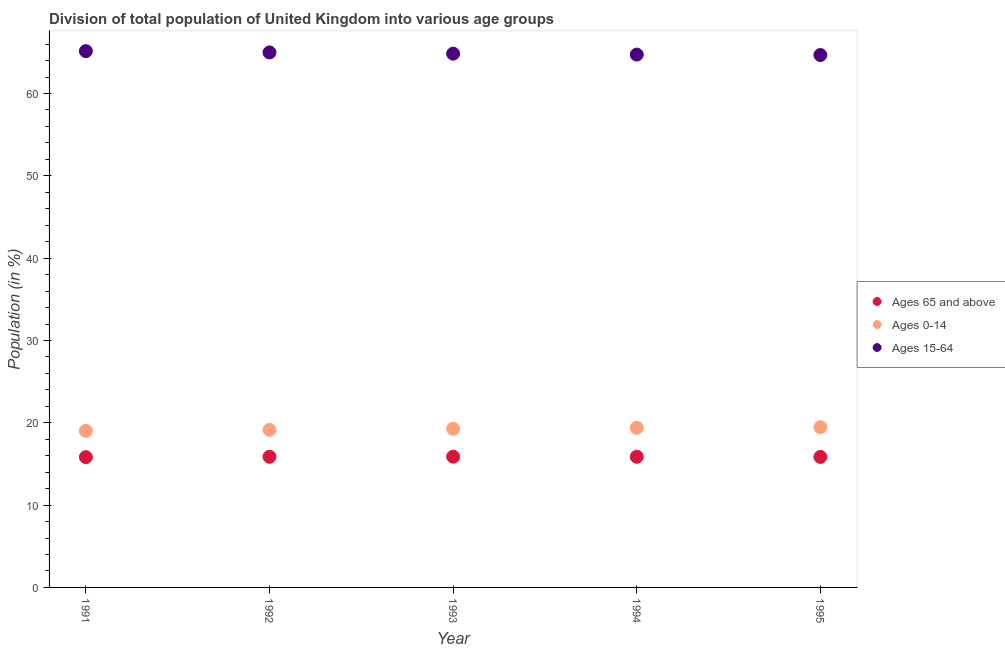What is the percentage of population within the age-group 15-64 in 1993?
Offer a very short reply. 64.84. Across all years, what is the maximum percentage of population within the age-group of 65 and above?
Ensure brevity in your answer.  15.88. Across all years, what is the minimum percentage of population within the age-group 0-14?
Provide a succinct answer. 19.03. In which year was the percentage of population within the age-group of 65 and above maximum?
Your answer should be compact. 1993. What is the total percentage of population within the age-group of 65 and above in the graph?
Ensure brevity in your answer.  79.31. What is the difference between the percentage of population within the age-group 15-64 in 1992 and that in 1994?
Offer a terse response. 0.26. What is the difference between the percentage of population within the age-group 15-64 in 1993 and the percentage of population within the age-group of 65 and above in 1991?
Offer a very short reply. 49.01. What is the average percentage of population within the age-group 15-64 per year?
Keep it short and to the point. 64.88. In the year 1991, what is the difference between the percentage of population within the age-group of 65 and above and percentage of population within the age-group 0-14?
Make the answer very short. -3.2. What is the ratio of the percentage of population within the age-group 15-64 in 1993 to that in 1994?
Provide a succinct answer. 1. What is the difference between the highest and the second highest percentage of population within the age-group 0-14?
Make the answer very short. 0.07. What is the difference between the highest and the lowest percentage of population within the age-group of 65 and above?
Keep it short and to the point. 0.06. Is the sum of the percentage of population within the age-group of 65 and above in 1994 and 1995 greater than the maximum percentage of population within the age-group 0-14 across all years?
Your answer should be compact. Yes. Is it the case that in every year, the sum of the percentage of population within the age-group of 65 and above and percentage of population within the age-group 0-14 is greater than the percentage of population within the age-group 15-64?
Your response must be concise. No. Does the percentage of population within the age-group 0-14 monotonically increase over the years?
Provide a short and direct response. Yes. How many years are there in the graph?
Your response must be concise. 5. What is the difference between two consecutive major ticks on the Y-axis?
Provide a short and direct response. 10. Are the values on the major ticks of Y-axis written in scientific E-notation?
Your response must be concise. No. What is the title of the graph?
Offer a terse response. Division of total population of United Kingdom into various age groups
. What is the label or title of the X-axis?
Give a very brief answer. Year. What is the Population (in %) of Ages 65 and above in 1991?
Your response must be concise. 15.83. What is the Population (in %) of Ages 0-14 in 1991?
Give a very brief answer. 19.03. What is the Population (in %) in Ages 15-64 in 1991?
Your response must be concise. 65.15. What is the Population (in %) of Ages 65 and above in 1992?
Offer a very short reply. 15.87. What is the Population (in %) of Ages 0-14 in 1992?
Provide a succinct answer. 19.14. What is the Population (in %) of Ages 15-64 in 1992?
Provide a short and direct response. 64.99. What is the Population (in %) in Ages 65 and above in 1993?
Provide a succinct answer. 15.88. What is the Population (in %) in Ages 0-14 in 1993?
Offer a very short reply. 19.28. What is the Population (in %) of Ages 15-64 in 1993?
Keep it short and to the point. 64.84. What is the Population (in %) in Ages 65 and above in 1994?
Provide a succinct answer. 15.87. What is the Population (in %) of Ages 0-14 in 1994?
Keep it short and to the point. 19.4. What is the Population (in %) of Ages 15-64 in 1994?
Keep it short and to the point. 64.73. What is the Population (in %) of Ages 65 and above in 1995?
Ensure brevity in your answer.  15.85. What is the Population (in %) of Ages 0-14 in 1995?
Your answer should be very brief. 19.47. What is the Population (in %) of Ages 15-64 in 1995?
Provide a short and direct response. 64.68. Across all years, what is the maximum Population (in %) of Ages 65 and above?
Your answer should be compact. 15.88. Across all years, what is the maximum Population (in %) in Ages 0-14?
Your answer should be very brief. 19.47. Across all years, what is the maximum Population (in %) in Ages 15-64?
Your response must be concise. 65.15. Across all years, what is the minimum Population (in %) in Ages 65 and above?
Offer a very short reply. 15.83. Across all years, what is the minimum Population (in %) of Ages 0-14?
Offer a very short reply. 19.03. Across all years, what is the minimum Population (in %) in Ages 15-64?
Make the answer very short. 64.68. What is the total Population (in %) in Ages 65 and above in the graph?
Make the answer very short. 79.31. What is the total Population (in %) of Ages 0-14 in the graph?
Your answer should be very brief. 96.3. What is the total Population (in %) in Ages 15-64 in the graph?
Make the answer very short. 324.38. What is the difference between the Population (in %) of Ages 65 and above in 1991 and that in 1992?
Your response must be concise. -0.05. What is the difference between the Population (in %) of Ages 0-14 in 1991 and that in 1992?
Keep it short and to the point. -0.11. What is the difference between the Population (in %) of Ages 15-64 in 1991 and that in 1992?
Offer a very short reply. 0.16. What is the difference between the Population (in %) in Ages 65 and above in 1991 and that in 1993?
Your answer should be very brief. -0.06. What is the difference between the Population (in %) of Ages 0-14 in 1991 and that in 1993?
Your answer should be compact. -0.25. What is the difference between the Population (in %) of Ages 15-64 in 1991 and that in 1993?
Provide a succinct answer. 0.31. What is the difference between the Population (in %) of Ages 65 and above in 1991 and that in 1994?
Make the answer very short. -0.05. What is the difference between the Population (in %) in Ages 0-14 in 1991 and that in 1994?
Offer a terse response. -0.37. What is the difference between the Population (in %) of Ages 15-64 in 1991 and that in 1994?
Keep it short and to the point. 0.42. What is the difference between the Population (in %) in Ages 65 and above in 1991 and that in 1995?
Your answer should be compact. -0.03. What is the difference between the Population (in %) in Ages 0-14 in 1991 and that in 1995?
Provide a short and direct response. -0.44. What is the difference between the Population (in %) of Ages 15-64 in 1991 and that in 1995?
Keep it short and to the point. 0.47. What is the difference between the Population (in %) of Ages 65 and above in 1992 and that in 1993?
Keep it short and to the point. -0.01. What is the difference between the Population (in %) of Ages 0-14 in 1992 and that in 1993?
Your response must be concise. -0.14. What is the difference between the Population (in %) of Ages 15-64 in 1992 and that in 1993?
Ensure brevity in your answer.  0.15. What is the difference between the Population (in %) of Ages 65 and above in 1992 and that in 1994?
Offer a terse response. -0. What is the difference between the Population (in %) of Ages 0-14 in 1992 and that in 1994?
Offer a very short reply. -0.26. What is the difference between the Population (in %) of Ages 15-64 in 1992 and that in 1994?
Offer a terse response. 0.26. What is the difference between the Population (in %) of Ages 65 and above in 1992 and that in 1995?
Ensure brevity in your answer.  0.02. What is the difference between the Population (in %) in Ages 0-14 in 1992 and that in 1995?
Offer a terse response. -0.33. What is the difference between the Population (in %) of Ages 15-64 in 1992 and that in 1995?
Ensure brevity in your answer.  0.32. What is the difference between the Population (in %) of Ages 65 and above in 1993 and that in 1994?
Your response must be concise. 0.01. What is the difference between the Population (in %) of Ages 0-14 in 1993 and that in 1994?
Provide a succinct answer. -0.12. What is the difference between the Population (in %) of Ages 15-64 in 1993 and that in 1994?
Your response must be concise. 0.11. What is the difference between the Population (in %) of Ages 65 and above in 1993 and that in 1995?
Provide a succinct answer. 0.03. What is the difference between the Population (in %) in Ages 0-14 in 1993 and that in 1995?
Provide a short and direct response. -0.19. What is the difference between the Population (in %) in Ages 15-64 in 1993 and that in 1995?
Provide a short and direct response. 0.16. What is the difference between the Population (in %) of Ages 65 and above in 1994 and that in 1995?
Provide a short and direct response. 0.02. What is the difference between the Population (in %) of Ages 0-14 in 1994 and that in 1995?
Your answer should be compact. -0.07. What is the difference between the Population (in %) in Ages 15-64 in 1994 and that in 1995?
Make the answer very short. 0.05. What is the difference between the Population (in %) of Ages 65 and above in 1991 and the Population (in %) of Ages 0-14 in 1992?
Your answer should be compact. -3.31. What is the difference between the Population (in %) in Ages 65 and above in 1991 and the Population (in %) in Ages 15-64 in 1992?
Make the answer very short. -49.17. What is the difference between the Population (in %) of Ages 0-14 in 1991 and the Population (in %) of Ages 15-64 in 1992?
Give a very brief answer. -45.97. What is the difference between the Population (in %) of Ages 65 and above in 1991 and the Population (in %) of Ages 0-14 in 1993?
Your answer should be compact. -3.45. What is the difference between the Population (in %) in Ages 65 and above in 1991 and the Population (in %) in Ages 15-64 in 1993?
Your answer should be very brief. -49.01. What is the difference between the Population (in %) in Ages 0-14 in 1991 and the Population (in %) in Ages 15-64 in 1993?
Offer a very short reply. -45.81. What is the difference between the Population (in %) of Ages 65 and above in 1991 and the Population (in %) of Ages 0-14 in 1994?
Offer a very short reply. -3.57. What is the difference between the Population (in %) in Ages 65 and above in 1991 and the Population (in %) in Ages 15-64 in 1994?
Give a very brief answer. -48.9. What is the difference between the Population (in %) of Ages 0-14 in 1991 and the Population (in %) of Ages 15-64 in 1994?
Your answer should be very brief. -45.7. What is the difference between the Population (in %) in Ages 65 and above in 1991 and the Population (in %) in Ages 0-14 in 1995?
Keep it short and to the point. -3.64. What is the difference between the Population (in %) in Ages 65 and above in 1991 and the Population (in %) in Ages 15-64 in 1995?
Give a very brief answer. -48.85. What is the difference between the Population (in %) of Ages 0-14 in 1991 and the Population (in %) of Ages 15-64 in 1995?
Your answer should be compact. -45.65. What is the difference between the Population (in %) in Ages 65 and above in 1992 and the Population (in %) in Ages 0-14 in 1993?
Keep it short and to the point. -3.4. What is the difference between the Population (in %) of Ages 65 and above in 1992 and the Population (in %) of Ages 15-64 in 1993?
Give a very brief answer. -48.97. What is the difference between the Population (in %) in Ages 0-14 in 1992 and the Population (in %) in Ages 15-64 in 1993?
Your answer should be compact. -45.7. What is the difference between the Population (in %) in Ages 65 and above in 1992 and the Population (in %) in Ages 0-14 in 1994?
Provide a succinct answer. -3.52. What is the difference between the Population (in %) of Ages 65 and above in 1992 and the Population (in %) of Ages 15-64 in 1994?
Ensure brevity in your answer.  -48.86. What is the difference between the Population (in %) of Ages 0-14 in 1992 and the Population (in %) of Ages 15-64 in 1994?
Give a very brief answer. -45.59. What is the difference between the Population (in %) of Ages 65 and above in 1992 and the Population (in %) of Ages 0-14 in 1995?
Your answer should be compact. -3.6. What is the difference between the Population (in %) in Ages 65 and above in 1992 and the Population (in %) in Ages 15-64 in 1995?
Give a very brief answer. -48.8. What is the difference between the Population (in %) in Ages 0-14 in 1992 and the Population (in %) in Ages 15-64 in 1995?
Keep it short and to the point. -45.54. What is the difference between the Population (in %) of Ages 65 and above in 1993 and the Population (in %) of Ages 0-14 in 1994?
Offer a very short reply. -3.51. What is the difference between the Population (in %) in Ages 65 and above in 1993 and the Population (in %) in Ages 15-64 in 1994?
Ensure brevity in your answer.  -48.84. What is the difference between the Population (in %) of Ages 0-14 in 1993 and the Population (in %) of Ages 15-64 in 1994?
Offer a very short reply. -45.45. What is the difference between the Population (in %) of Ages 65 and above in 1993 and the Population (in %) of Ages 0-14 in 1995?
Provide a succinct answer. -3.59. What is the difference between the Population (in %) in Ages 65 and above in 1993 and the Population (in %) in Ages 15-64 in 1995?
Provide a succinct answer. -48.79. What is the difference between the Population (in %) in Ages 0-14 in 1993 and the Population (in %) in Ages 15-64 in 1995?
Offer a very short reply. -45.4. What is the difference between the Population (in %) of Ages 65 and above in 1994 and the Population (in %) of Ages 0-14 in 1995?
Your answer should be very brief. -3.59. What is the difference between the Population (in %) of Ages 65 and above in 1994 and the Population (in %) of Ages 15-64 in 1995?
Your answer should be very brief. -48.8. What is the difference between the Population (in %) in Ages 0-14 in 1994 and the Population (in %) in Ages 15-64 in 1995?
Offer a terse response. -45.28. What is the average Population (in %) in Ages 65 and above per year?
Offer a terse response. 15.86. What is the average Population (in %) in Ages 0-14 per year?
Provide a short and direct response. 19.26. What is the average Population (in %) in Ages 15-64 per year?
Give a very brief answer. 64.88. In the year 1991, what is the difference between the Population (in %) of Ages 65 and above and Population (in %) of Ages 0-14?
Your answer should be very brief. -3.2. In the year 1991, what is the difference between the Population (in %) of Ages 65 and above and Population (in %) of Ages 15-64?
Your answer should be very brief. -49.32. In the year 1991, what is the difference between the Population (in %) in Ages 0-14 and Population (in %) in Ages 15-64?
Give a very brief answer. -46.12. In the year 1992, what is the difference between the Population (in %) in Ages 65 and above and Population (in %) in Ages 0-14?
Offer a terse response. -3.26. In the year 1992, what is the difference between the Population (in %) in Ages 65 and above and Population (in %) in Ages 15-64?
Your answer should be very brief. -49.12. In the year 1992, what is the difference between the Population (in %) of Ages 0-14 and Population (in %) of Ages 15-64?
Give a very brief answer. -45.85. In the year 1993, what is the difference between the Population (in %) in Ages 65 and above and Population (in %) in Ages 0-14?
Give a very brief answer. -3.39. In the year 1993, what is the difference between the Population (in %) in Ages 65 and above and Population (in %) in Ages 15-64?
Your answer should be compact. -48.96. In the year 1993, what is the difference between the Population (in %) in Ages 0-14 and Population (in %) in Ages 15-64?
Keep it short and to the point. -45.56. In the year 1994, what is the difference between the Population (in %) of Ages 65 and above and Population (in %) of Ages 0-14?
Provide a succinct answer. -3.52. In the year 1994, what is the difference between the Population (in %) in Ages 65 and above and Population (in %) in Ages 15-64?
Provide a succinct answer. -48.85. In the year 1994, what is the difference between the Population (in %) in Ages 0-14 and Population (in %) in Ages 15-64?
Give a very brief answer. -45.33. In the year 1995, what is the difference between the Population (in %) in Ages 65 and above and Population (in %) in Ages 0-14?
Provide a short and direct response. -3.61. In the year 1995, what is the difference between the Population (in %) in Ages 65 and above and Population (in %) in Ages 15-64?
Offer a very short reply. -48.82. In the year 1995, what is the difference between the Population (in %) in Ages 0-14 and Population (in %) in Ages 15-64?
Provide a short and direct response. -45.21. What is the ratio of the Population (in %) in Ages 65 and above in 1991 to that in 1992?
Offer a terse response. 1. What is the ratio of the Population (in %) in Ages 65 and above in 1991 to that in 1993?
Provide a short and direct response. 1. What is the ratio of the Population (in %) of Ages 15-64 in 1991 to that in 1993?
Make the answer very short. 1. What is the ratio of the Population (in %) of Ages 0-14 in 1991 to that in 1994?
Offer a very short reply. 0.98. What is the ratio of the Population (in %) in Ages 65 and above in 1991 to that in 1995?
Give a very brief answer. 1. What is the ratio of the Population (in %) of Ages 0-14 in 1991 to that in 1995?
Your answer should be compact. 0.98. What is the ratio of the Population (in %) in Ages 15-64 in 1991 to that in 1995?
Your answer should be compact. 1.01. What is the ratio of the Population (in %) of Ages 65 and above in 1992 to that in 1994?
Make the answer very short. 1. What is the ratio of the Population (in %) in Ages 0-14 in 1992 to that in 1994?
Provide a succinct answer. 0.99. What is the ratio of the Population (in %) in Ages 0-14 in 1992 to that in 1995?
Your answer should be compact. 0.98. What is the ratio of the Population (in %) of Ages 65 and above in 1993 to that in 1995?
Offer a very short reply. 1. What is the ratio of the Population (in %) in Ages 0-14 in 1994 to that in 1995?
Your response must be concise. 1. What is the difference between the highest and the second highest Population (in %) of Ages 65 and above?
Your answer should be compact. 0.01. What is the difference between the highest and the second highest Population (in %) in Ages 0-14?
Make the answer very short. 0.07. What is the difference between the highest and the second highest Population (in %) of Ages 15-64?
Give a very brief answer. 0.16. What is the difference between the highest and the lowest Population (in %) in Ages 65 and above?
Offer a terse response. 0.06. What is the difference between the highest and the lowest Population (in %) of Ages 0-14?
Keep it short and to the point. 0.44. What is the difference between the highest and the lowest Population (in %) in Ages 15-64?
Make the answer very short. 0.47. 